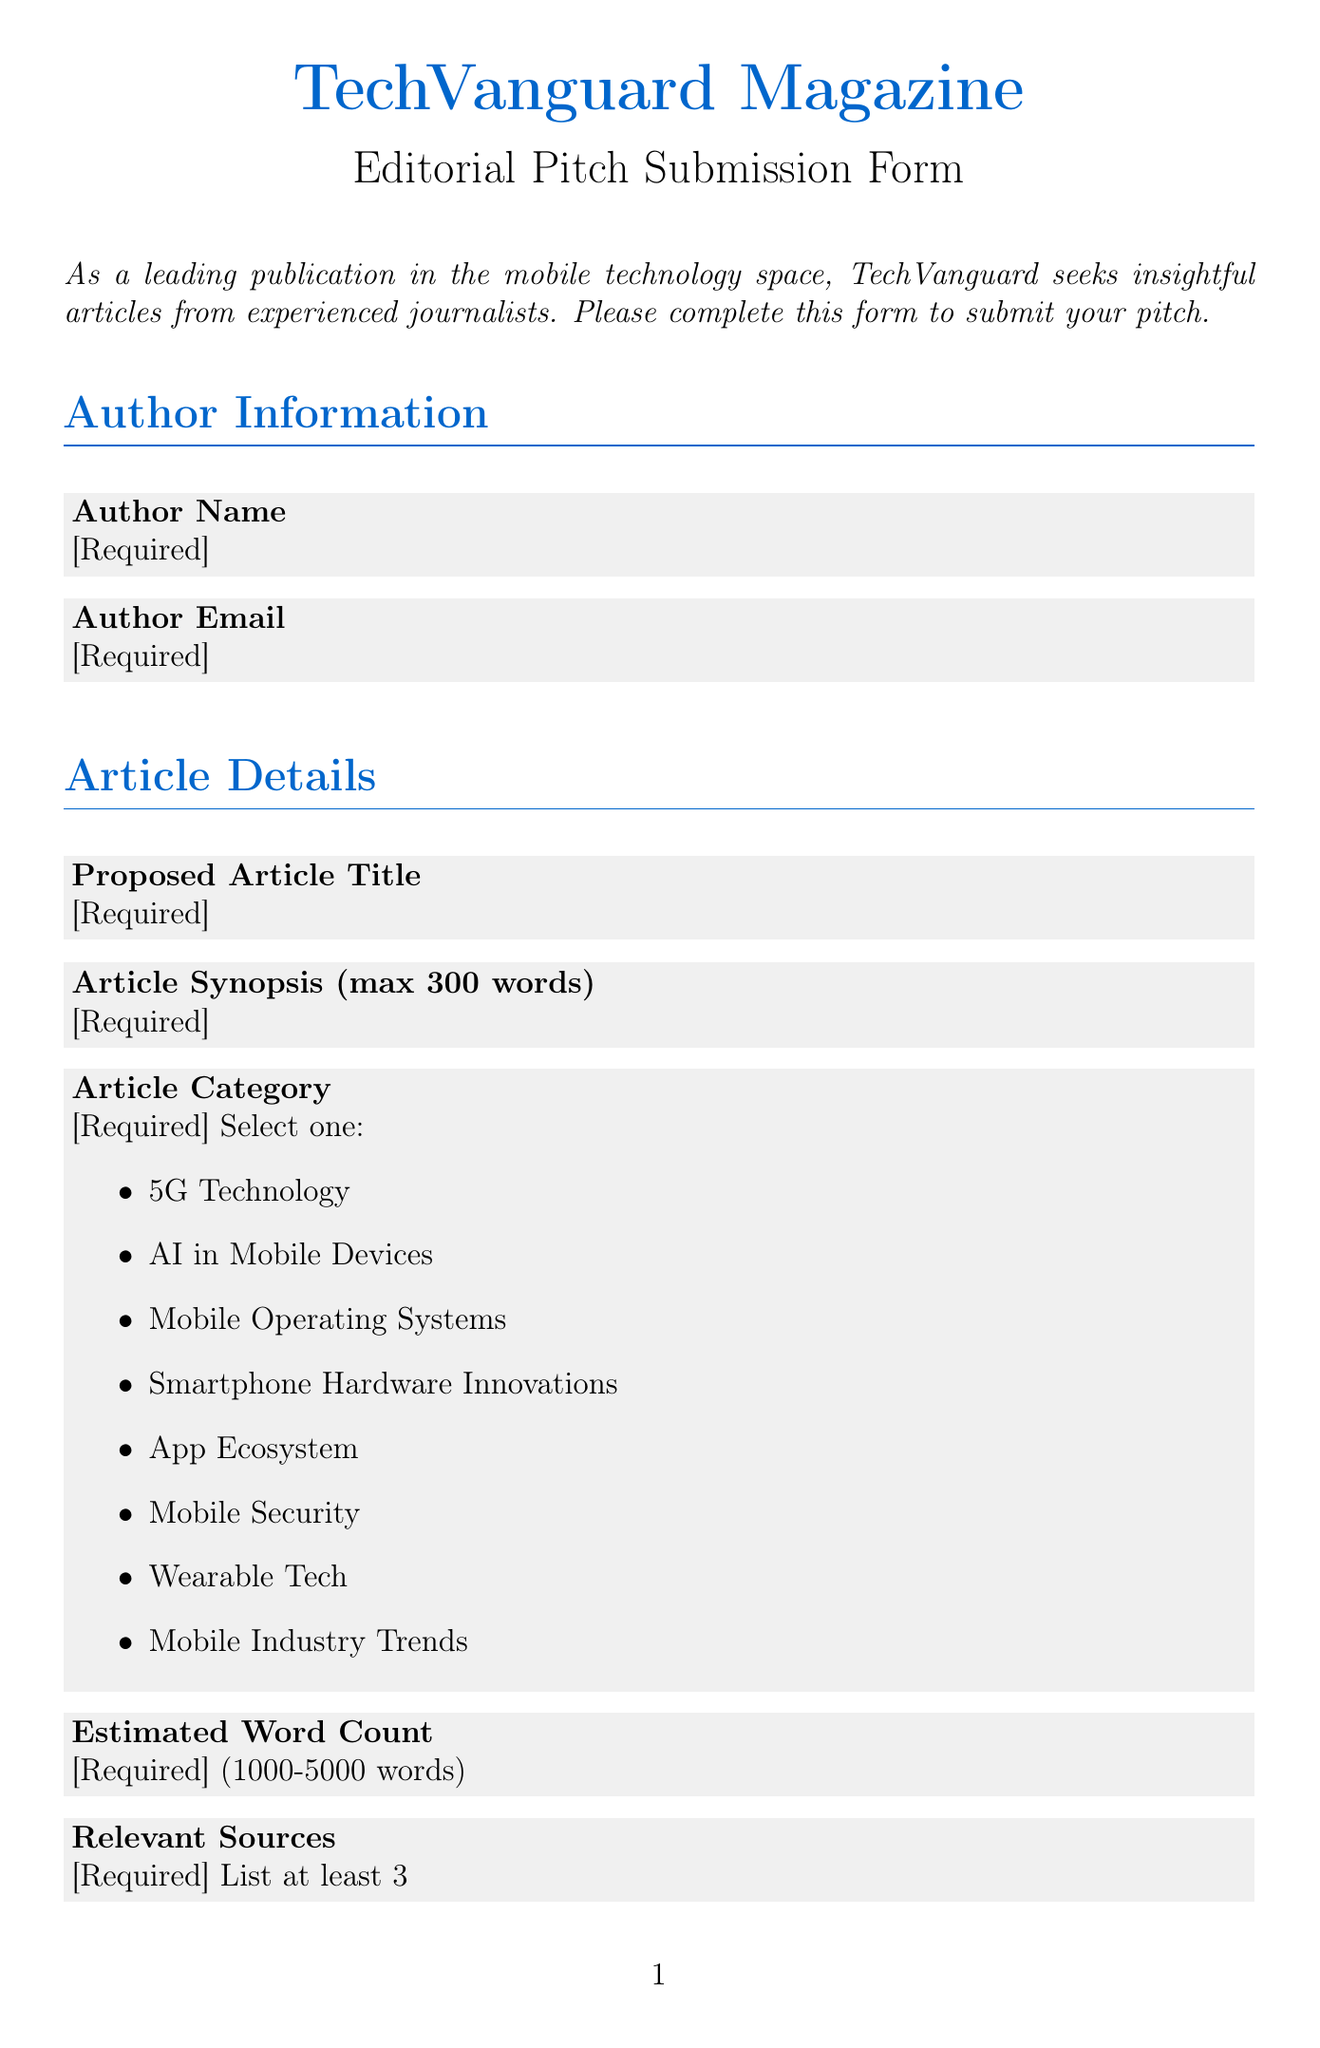What is the title of the form? The title of the form is the name of the submission form as indicated in the document.
Answer: TechVanguard Magazine Editorial Pitch Submission How many article categories are available? The document lists the options available for article categories in the dropdown menu.
Answer: 8 What is the maximum length of the article synopsis? The maximum length is specifically stated in the associated field label.
Answer: 300 words What is the minimum estimated word count for submissions? The document specifies the minimum and maximum word count limits for article submissions.
Answer: 1000 Is exclusivity required for the pitch submission? The document asks a specific question in a radio field related to exclusivity, indicating its importance.
Answer: Yes What contact email is provided for submissions? The document includes contact information for submissions, specifically an email address.
Answer: submissions@techvanguard.com What are the maximum previous publications to list? The field for previous publications specifies how many articles can be listed by the author.
Answer: 3 What is the proposed timeline option that indicates the shortest submission time? The document lists several proposed timelines for submission and the shortest one is clearly stated.
Answer: 1 week What is one requirement stated in the submission guidelines? One of the guideline points clearly outlines what should be ensured when submitting a pitch.
Answer: Ensure your pitch aligns with TechVanguard's focus on cutting-edge mobile technology 